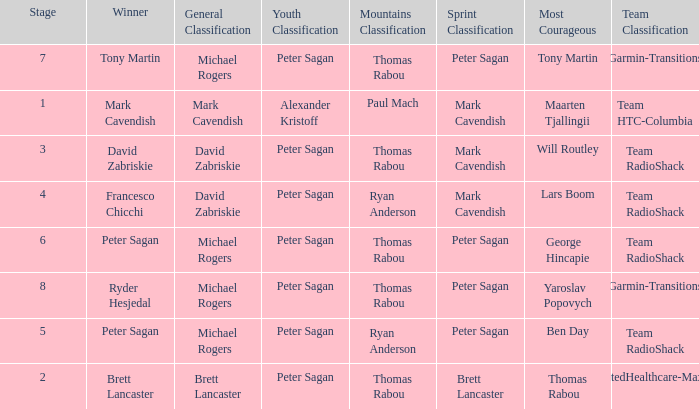When Peter Sagan won the youth classification and Thomas Rabou won the most corageous, who won the sprint classification? Brett Lancaster. 